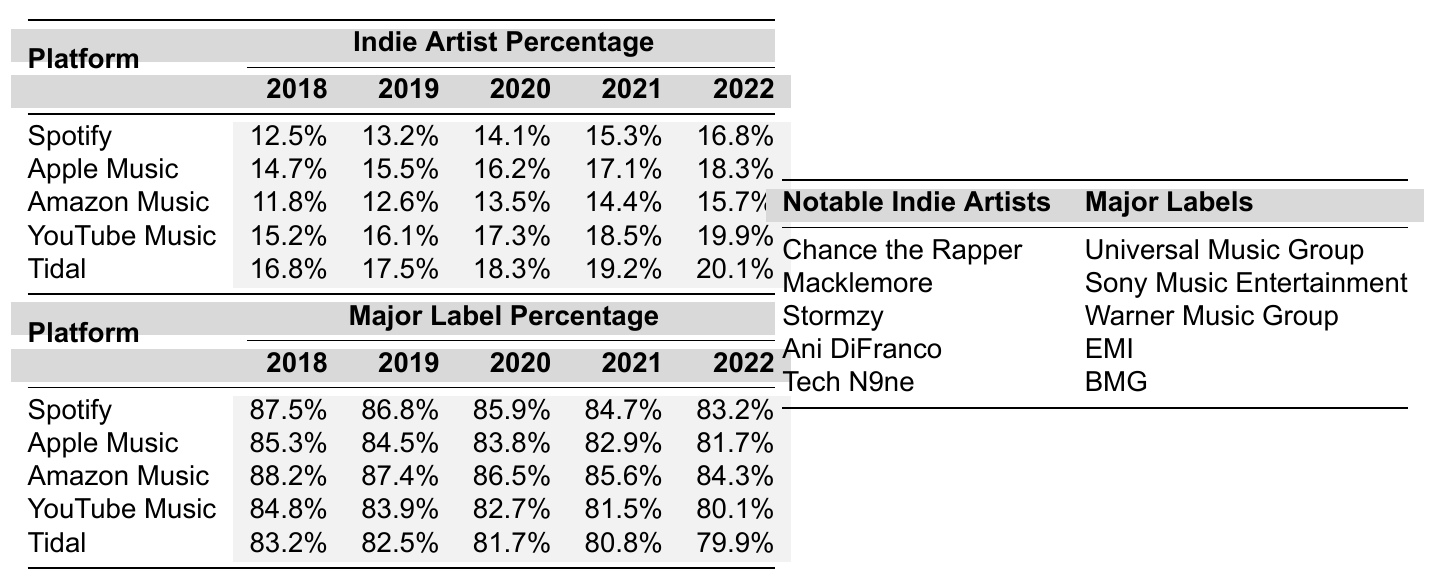What was the indie artist percentage on Spotify in 2022? Referring to the table, the indie artist percentage on Spotify for the year 2022 is listed as 16.8% in the corresponding row.
Answer: 16.8% Which platform had the highest indie artist percentage in 2021? In 2021, the indie artist percentages for each platform are: Spotify (15.3%), Apple Music (17.1%), Amazon Music (14.4%), YouTube Music (18.5%), and Tidal (19.2%). The highest among these is Tidal at 19.2%.
Answer: Tidal What is the difference between indie artist percentages on Apple Music in 2018 and 2022? The indie artist percentage for Apple Music in 2018 is 14.7% and in 2022 is 18.3%. To find the difference, subtract 14.7 from 18.3, which equals 3.6%.
Answer: 3.6% Was the indie artist percentage on Amazon Music higher than that of Spotify in 2019? The indie artist percentage on Amazon Music in 2019 is 12.6% and on Spotify is 13.2%. Since 12.6% is less than 13.2%, the statement is false.
Answer: No What is the average percentage of streaming royalties received by major label artists on YouTube Music from 2018 to 2022? The percentages for major label artists on YouTube Music from 2018 to 2022 are 84.8%, 83.9%, 82.7%, 81.5%, and 80.1%. To calculate the average: (84.8 + 83.9 + 82.7 + 81.5 + 80.1) / 5 = 82.6%.
Answer: 82.6% Which streaming platform shows the most consistent indie artist percentage growth from 2018 to 2022? By examining the percentages, we calculate the increase for each platform: Spotify (4.3%), Apple Music (3.6%), Amazon Music (3.9%), YouTube Music (4.7%), and Tidal (3.3%). YouTube Music has the highest increase of 4.7%, indicating the most consistent growth.
Answer: YouTube Music Was the indie artist percentage on Tidal in 2022 lower than the major label percentage on the same platform? The indie artist percentage on Tidal in 2022 is 20.1%, while the major label percentage is 79.9%. Since 20.1% is less than 79.9%, this statement is true.
Answer: Yes What is the trend of the indie artist percentages on Spotify over the years according to the data? The percentages for indie artists on Spotify from 2018 to 2022 are 12.5%, 13.2%, 14.1%, 15.3%, and 16.8%. Each of these values increases year-over-year, indicating a consistent upward trend.
Answer: Upward trend How does the major label percentage on Amazon Music in 2020 compare to that of YouTube Music in the same year? The major label percentage on Amazon Music in 2020 is 86.5%, while on YouTube Music, it is 82.7%. Comparing the two, 86.5% is higher than 82.7%, so Amazon Music has a greater percentage.
Answer: Amazon Music is higher What is the percentage of streaming royalties received by indie artists on all platforms combined in 2021? To find the combined indie artist percentage for 2021, we add the individual percentages: 15.3% (Spotify) + 17.1% (Apple Music) + 14.4% (Amazon Music) + 18.5% (YouTube Music) + 19.2% (Tidal) = 84.5%.
Answer: 84.5% 